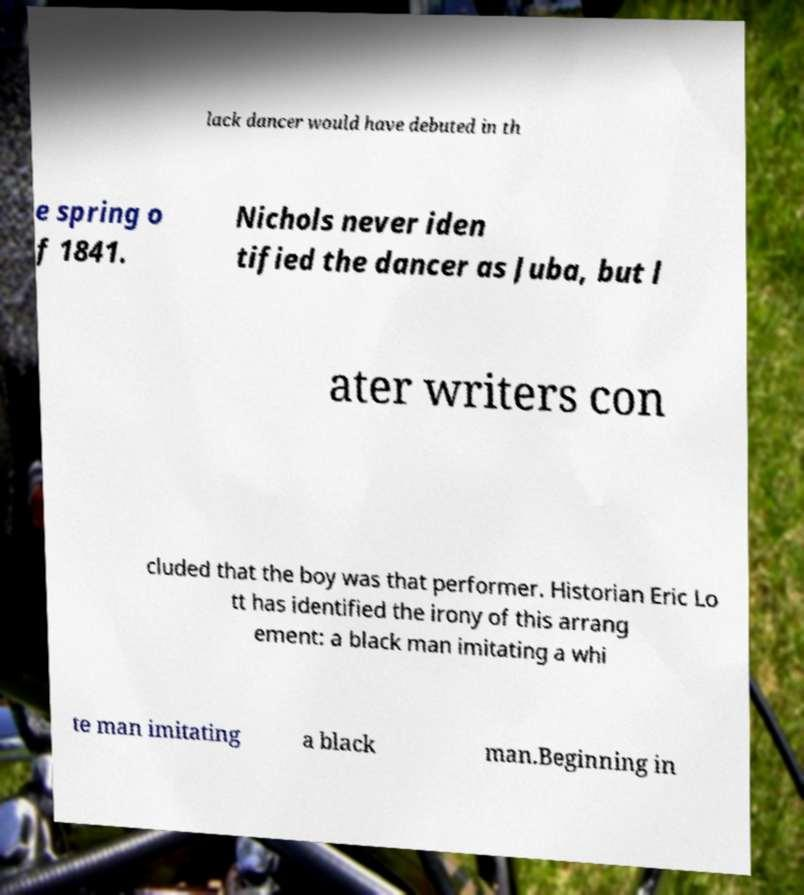What messages or text are displayed in this image? I need them in a readable, typed format. lack dancer would have debuted in th e spring o f 1841. Nichols never iden tified the dancer as Juba, but l ater writers con cluded that the boy was that performer. Historian Eric Lo tt has identified the irony of this arrang ement: a black man imitating a whi te man imitating a black man.Beginning in 